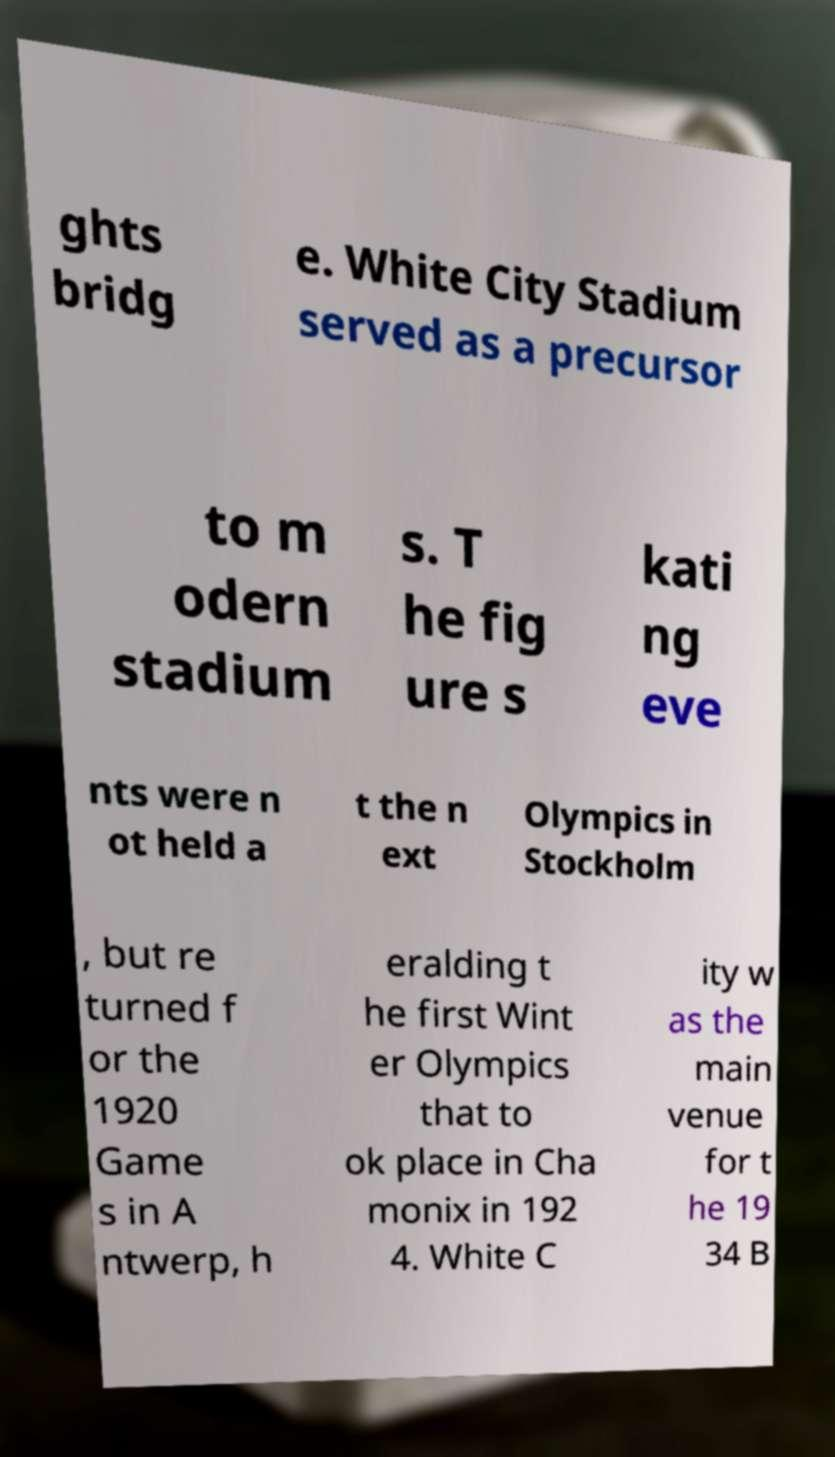Can you accurately transcribe the text from the provided image for me? ghts bridg e. White City Stadium served as a precursor to m odern stadium s. T he fig ure s kati ng eve nts were n ot held a t the n ext Olympics in Stockholm , but re turned f or the 1920 Game s in A ntwerp, h eralding t he first Wint er Olympics that to ok place in Cha monix in 192 4. White C ity w as the main venue for t he 19 34 B 